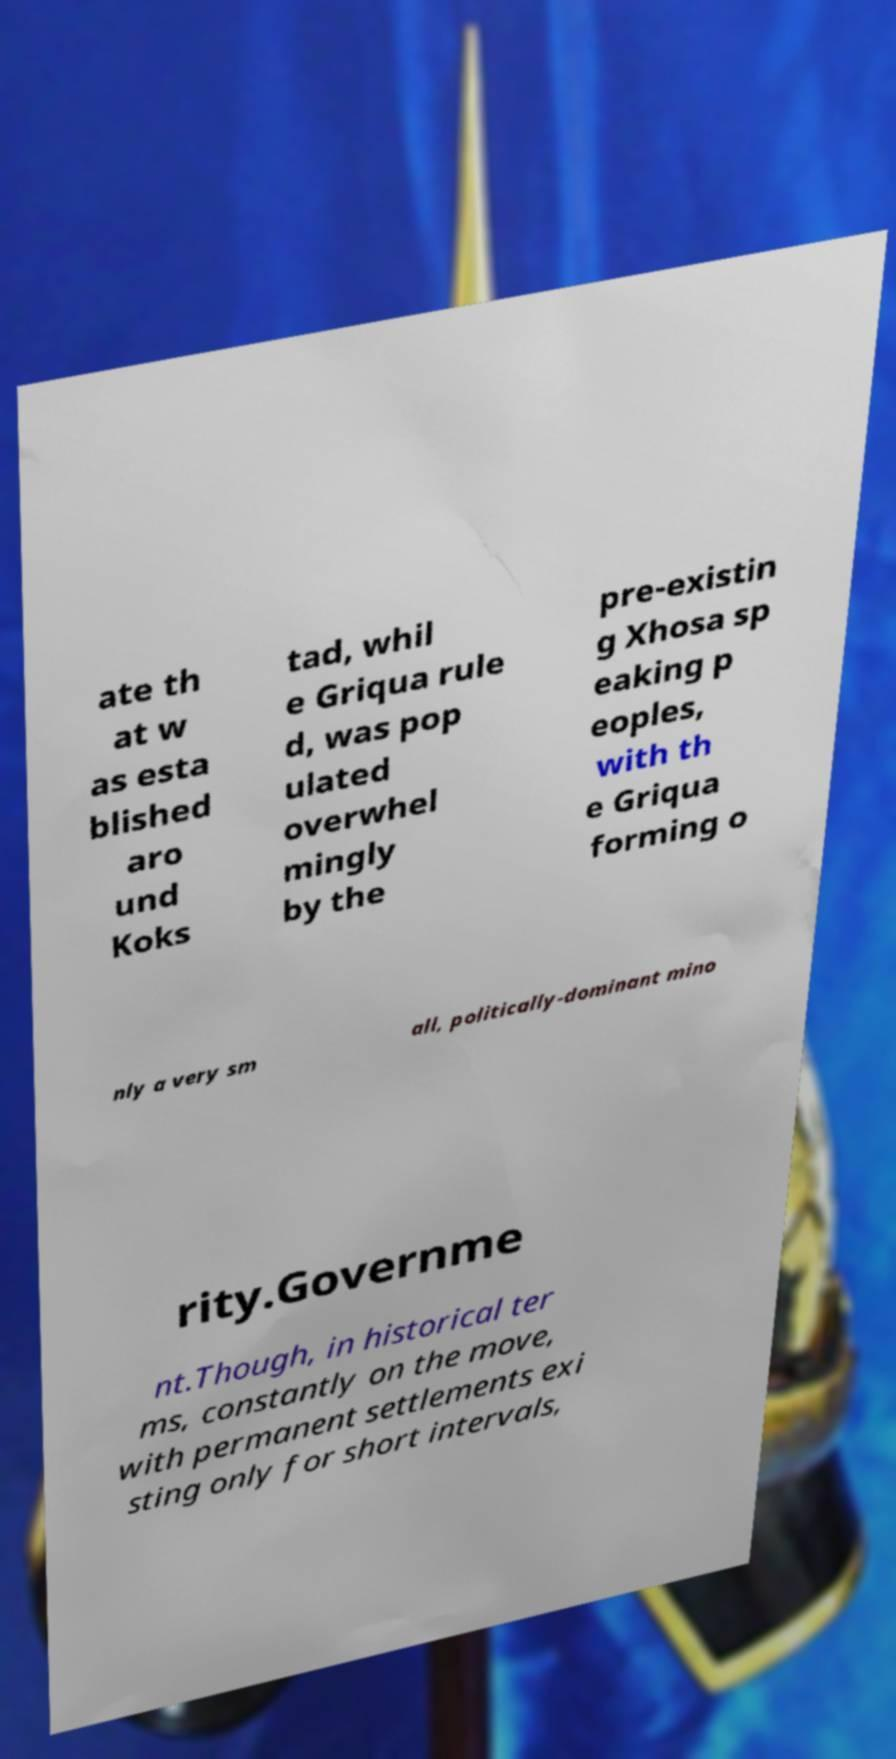I need the written content from this picture converted into text. Can you do that? ate th at w as esta blished aro und Koks tad, whil e Griqua rule d, was pop ulated overwhel mingly by the pre-existin g Xhosa sp eaking p eoples, with th e Griqua forming o nly a very sm all, politically-dominant mino rity.Governme nt.Though, in historical ter ms, constantly on the move, with permanent settlements exi sting only for short intervals, 